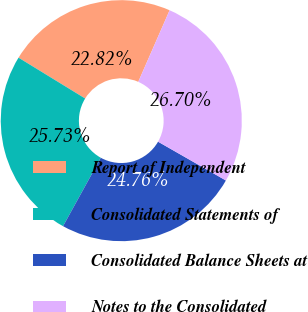Convert chart. <chart><loc_0><loc_0><loc_500><loc_500><pie_chart><fcel>Report of Independent<fcel>Consolidated Statements of<fcel>Consolidated Balance Sheets at<fcel>Notes to the Consolidated<nl><fcel>22.82%<fcel>25.73%<fcel>24.76%<fcel>26.7%<nl></chart> 